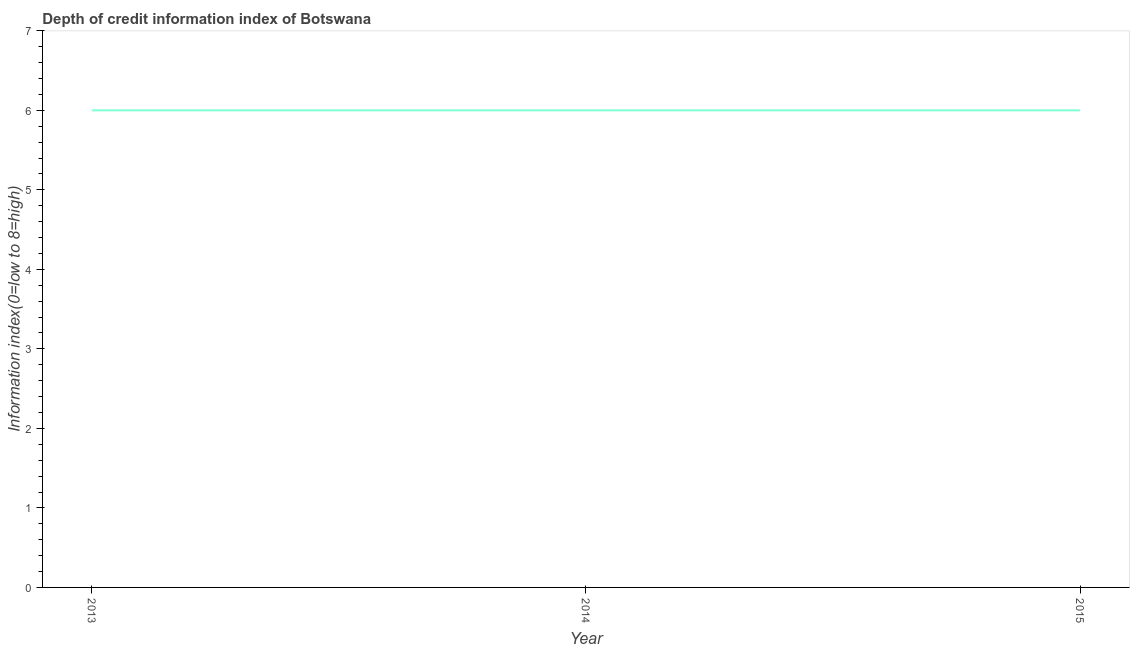What is the depth of credit information index in 2015?
Your answer should be compact. 6. Across all years, what is the maximum depth of credit information index?
Ensure brevity in your answer.  6. Across all years, what is the minimum depth of credit information index?
Keep it short and to the point. 6. In which year was the depth of credit information index maximum?
Your answer should be compact. 2013. What is the sum of the depth of credit information index?
Give a very brief answer. 18. What is the difference between the depth of credit information index in 2013 and 2015?
Offer a terse response. 0. Is the difference between the depth of credit information index in 2013 and 2014 greater than the difference between any two years?
Provide a succinct answer. Yes. What is the difference between the highest and the second highest depth of credit information index?
Keep it short and to the point. 0. What is the difference between the highest and the lowest depth of credit information index?
Offer a terse response. 0. Does the depth of credit information index monotonically increase over the years?
Provide a short and direct response. No. How many lines are there?
Keep it short and to the point. 1. How many years are there in the graph?
Your answer should be very brief. 3. What is the title of the graph?
Provide a succinct answer. Depth of credit information index of Botswana. What is the label or title of the Y-axis?
Your answer should be compact. Information index(0=low to 8=high). What is the difference between the Information index(0=low to 8=high) in 2013 and 2014?
Provide a short and direct response. 0. What is the ratio of the Information index(0=low to 8=high) in 2013 to that in 2014?
Offer a terse response. 1. 